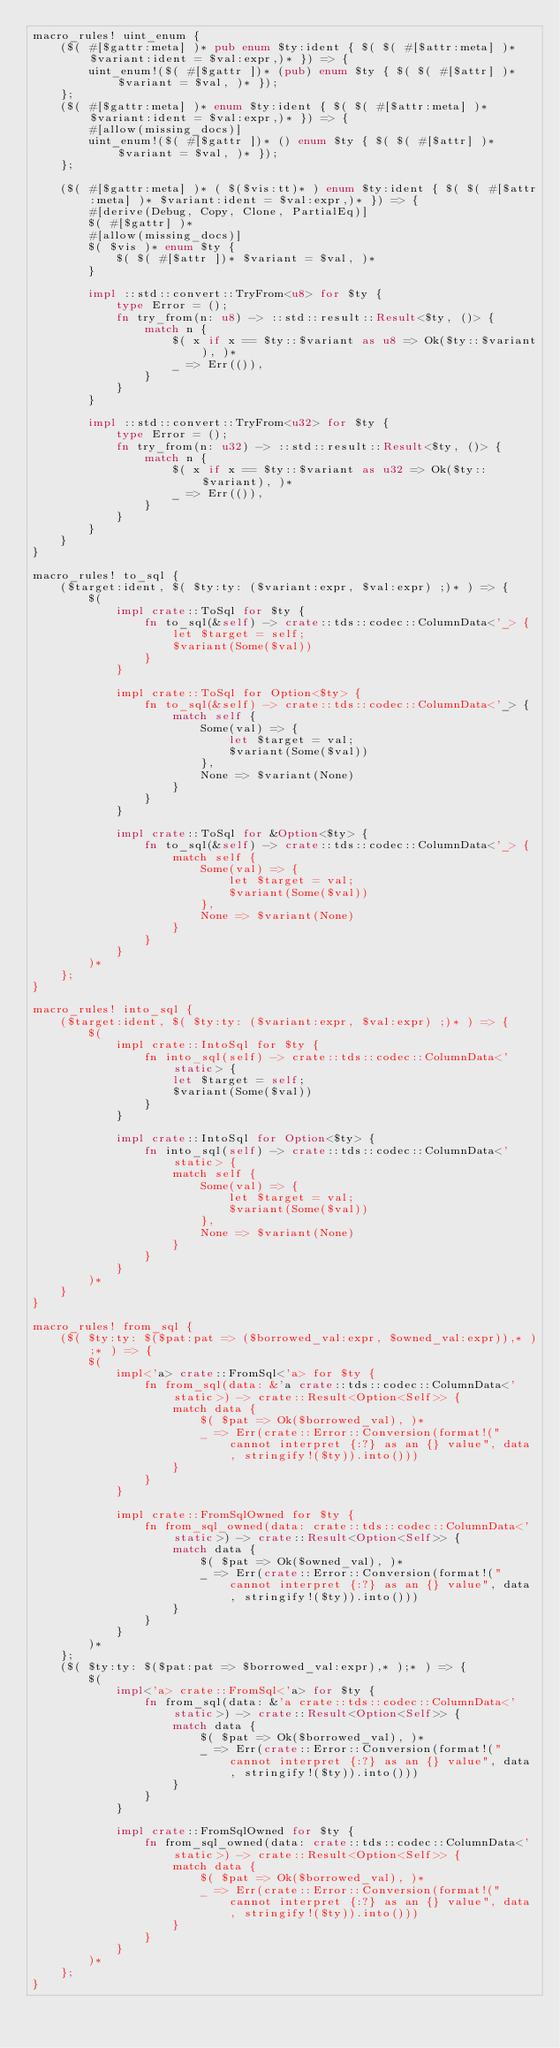<code> <loc_0><loc_0><loc_500><loc_500><_Rust_>macro_rules! uint_enum {
    ($( #[$gattr:meta] )* pub enum $ty:ident { $( $( #[$attr:meta] )* $variant:ident = $val:expr,)* }) => {
        uint_enum!($( #[$gattr ])* (pub) enum $ty { $( $( #[$attr] )* $variant = $val, )* });
    };
    ($( #[$gattr:meta] )* enum $ty:ident { $( $( #[$attr:meta] )* $variant:ident = $val:expr,)* }) => {
        #[allow(missing_docs)]
        uint_enum!($( #[$gattr ])* () enum $ty { $( $( #[$attr] )* $variant = $val, )* });
    };

    ($( #[$gattr:meta] )* ( $($vis:tt)* ) enum $ty:ident { $( $( #[$attr:meta] )* $variant:ident = $val:expr,)* }) => {
        #[derive(Debug, Copy, Clone, PartialEq)]
        $( #[$gattr] )*
        #[allow(missing_docs)]
        $( $vis )* enum $ty {
            $( $( #[$attr ])* $variant = $val, )*
        }

        impl ::std::convert::TryFrom<u8> for $ty {
            type Error = ();
            fn try_from(n: u8) -> ::std::result::Result<$ty, ()> {
                match n {
                    $( x if x == $ty::$variant as u8 => Ok($ty::$variant), )*
                    _ => Err(()),
                }
            }
        }

        impl ::std::convert::TryFrom<u32> for $ty {
            type Error = ();
            fn try_from(n: u32) -> ::std::result::Result<$ty, ()> {
                match n {
                    $( x if x == $ty::$variant as u32 => Ok($ty::$variant), )*
                    _ => Err(()),
                }
            }
        }
    }
}

macro_rules! to_sql {
    ($target:ident, $( $ty:ty: ($variant:expr, $val:expr) ;)* ) => {
        $(
            impl crate::ToSql for $ty {
                fn to_sql(&self) -> crate::tds::codec::ColumnData<'_> {
                    let $target = self;
                    $variant(Some($val))
                }
            }

            impl crate::ToSql for Option<$ty> {
                fn to_sql(&self) -> crate::tds::codec::ColumnData<'_> {
                    match self {
                        Some(val) => {
                            let $target = val;
                            $variant(Some($val))
                        },
                        None => $variant(None)
                    }
                }
            }

            impl crate::ToSql for &Option<$ty> {
                fn to_sql(&self) -> crate::tds::codec::ColumnData<'_> {
                    match self {
                        Some(val) => {
                            let $target = val;
                            $variant(Some($val))
                        },
                        None => $variant(None)
                    }
                }
            }
        )*
    };
}

macro_rules! into_sql {
    ($target:ident, $( $ty:ty: ($variant:expr, $val:expr) ;)* ) => {
        $(
            impl crate::IntoSql for $ty {
                fn into_sql(self) -> crate::tds::codec::ColumnData<'static> {
                    let $target = self;
                    $variant(Some($val))
                }
            }

            impl crate::IntoSql for Option<$ty> {
                fn into_sql(self) -> crate::tds::codec::ColumnData<'static> {
                    match self {
                        Some(val) => {
                            let $target = val;
                            $variant(Some($val))
                        },
                        None => $variant(None)
                    }
                }
            }
        )*
    }
}

macro_rules! from_sql {
    ($( $ty:ty: $($pat:pat => ($borrowed_val:expr, $owned_val:expr)),* );* ) => {
        $(
            impl<'a> crate::FromSql<'a> for $ty {
                fn from_sql(data: &'a crate::tds::codec::ColumnData<'static>) -> crate::Result<Option<Self>> {
                    match data {
                        $( $pat => Ok($borrowed_val), )*
                        _ => Err(crate::Error::Conversion(format!("cannot interpret {:?} as an {} value", data, stringify!($ty)).into()))
                    }
                }
            }

            impl crate::FromSqlOwned for $ty {
                fn from_sql_owned(data: crate::tds::codec::ColumnData<'static>) -> crate::Result<Option<Self>> {
                    match data {
                        $( $pat => Ok($owned_val), )*
                        _ => Err(crate::Error::Conversion(format!("cannot interpret {:?} as an {} value", data, stringify!($ty)).into()))
                    }
                }
            }
        )*
    };
    ($( $ty:ty: $($pat:pat => $borrowed_val:expr),* );* ) => {
        $(
            impl<'a> crate::FromSql<'a> for $ty {
                fn from_sql(data: &'a crate::tds::codec::ColumnData<'static>) -> crate::Result<Option<Self>> {
                    match data {
                        $( $pat => Ok($borrowed_val), )*
                        _ => Err(crate::Error::Conversion(format!("cannot interpret {:?} as an {} value", data, stringify!($ty)).into()))
                    }
                }
            }

            impl crate::FromSqlOwned for $ty {
                fn from_sql_owned(data: crate::tds::codec::ColumnData<'static>) -> crate::Result<Option<Self>> {
                    match data {
                        $( $pat => Ok($borrowed_val), )*
                        _ => Err(crate::Error::Conversion(format!("cannot interpret {:?} as an {} value", data, stringify!($ty)).into()))
                    }
                }
            }
        )*
    };
}
</code> 